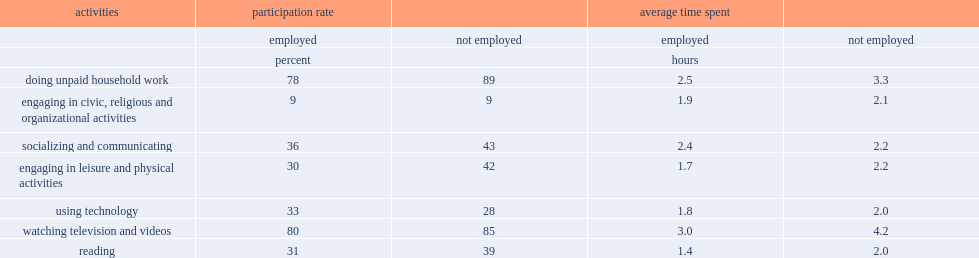Who are less in doing unpaid household work,seniors who continue to work or those who are not employed? Employed. Who had a higher participation rate in engaging in leisure and physical activities,those who are not employed or those who are employed? Not employed. Who are more likely to spend additional time on engaging in leisure and physical activities,seniors who are not employed or those employed? Not employed. Who had a higher participation rate for reading,those who are not employed or the employed? Not employed. How many hours did those who are not employed spend on watching television than those employed? 1.2. Who spend more time on reading,seniors who are not employed or those who are still employed? Not employed. 